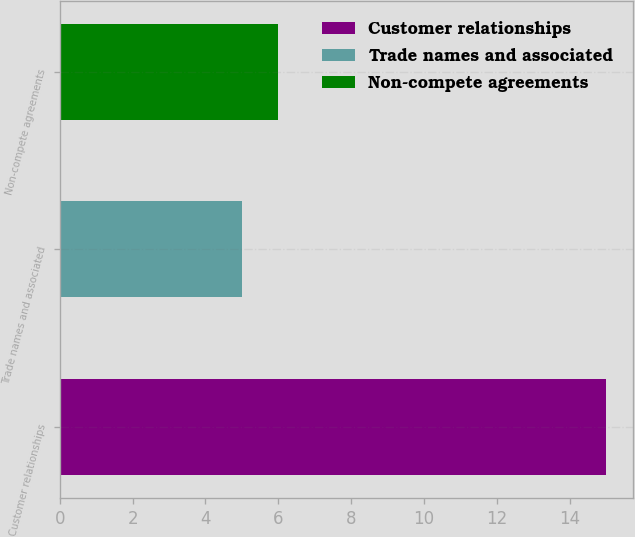Convert chart to OTSL. <chart><loc_0><loc_0><loc_500><loc_500><bar_chart><fcel>Customer relationships<fcel>Trade names and associated<fcel>Non-compete agreements<nl><fcel>15<fcel>5<fcel>6<nl></chart> 